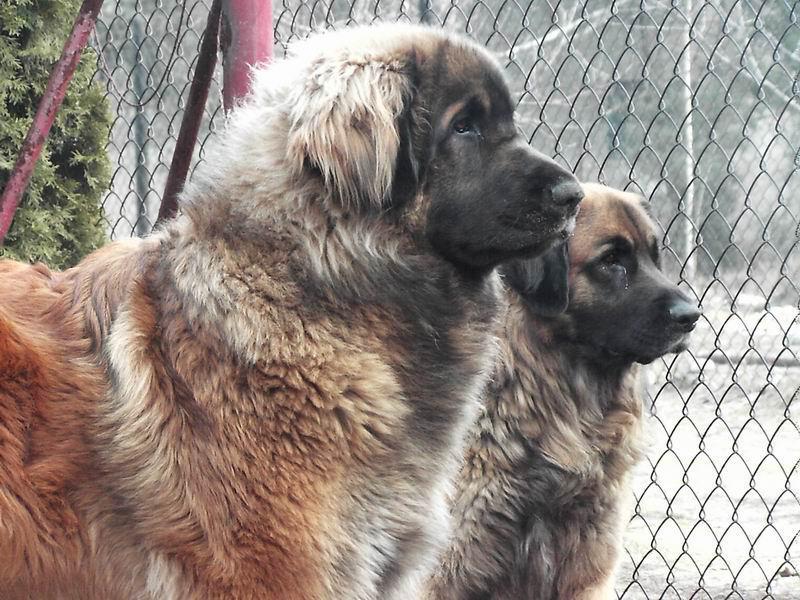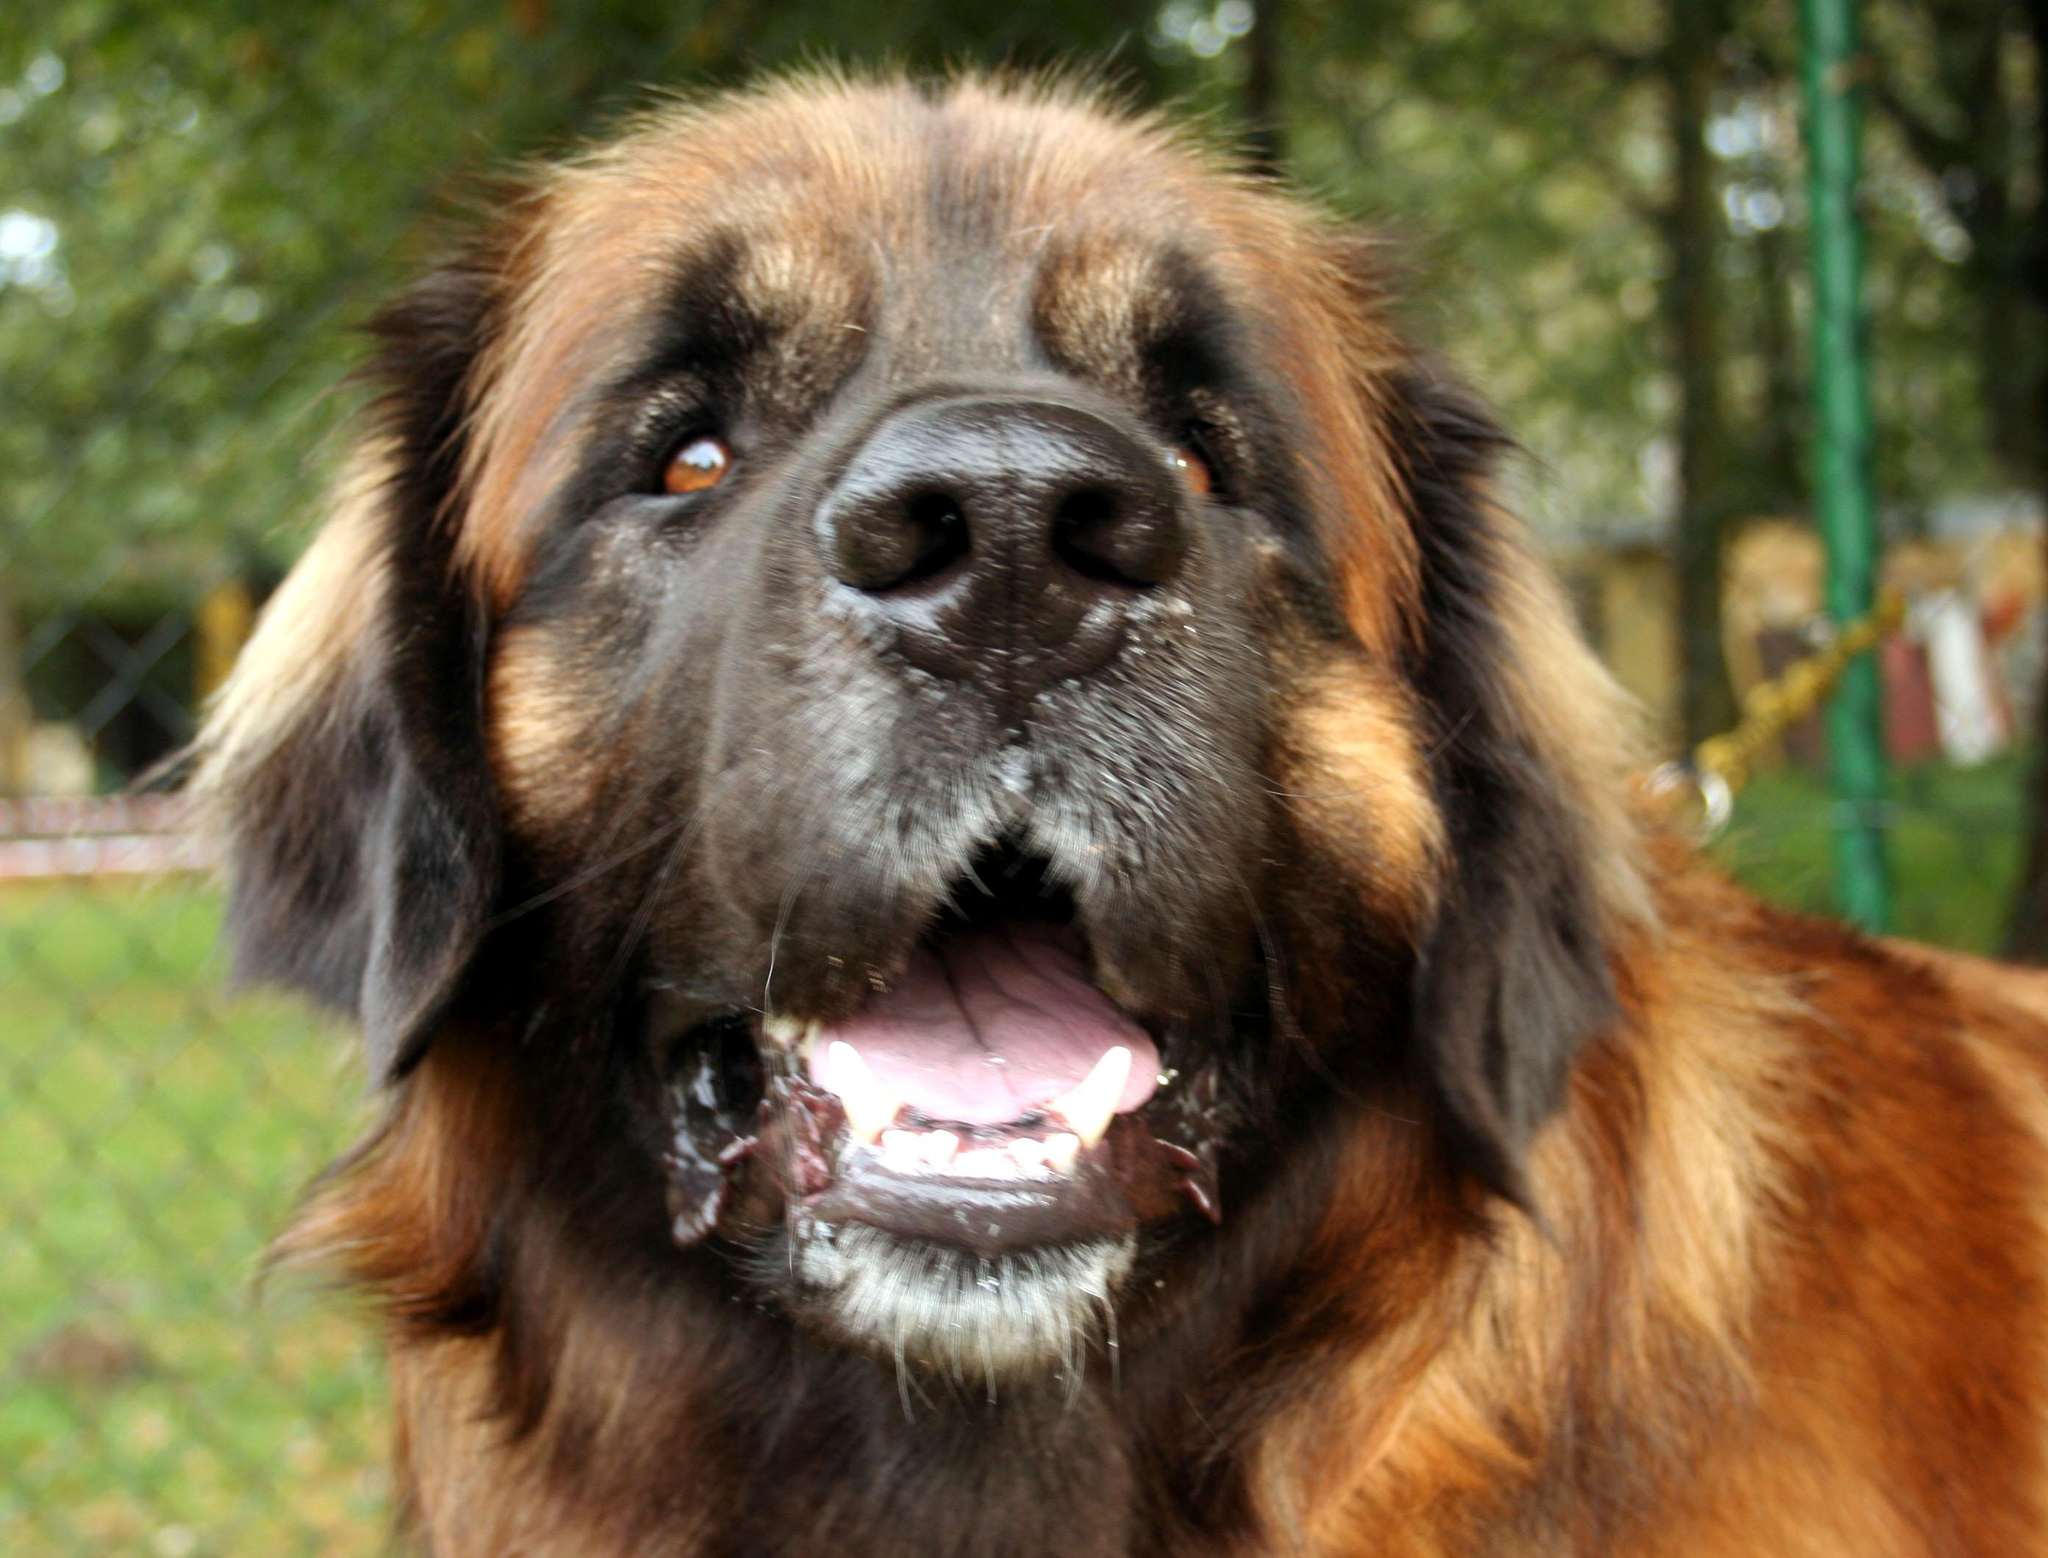The first image is the image on the left, the second image is the image on the right. Examine the images to the left and right. Is the description "Two dogs in similar poses are facing some type of fence in one image." accurate? Answer yes or no. Yes. The first image is the image on the left, the second image is the image on the right. For the images displayed, is the sentence "In one image, two dogs of the same breed are near a fence, while the other image shows a single dog with its mouth open and tongue visible." factually correct? Answer yes or no. Yes. 